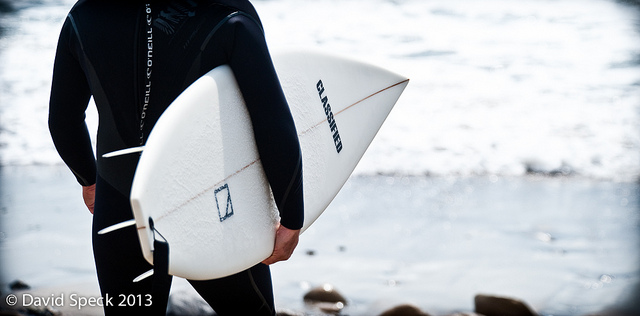Read all the text in this image. David Speck 2013 CLASSIFIED 